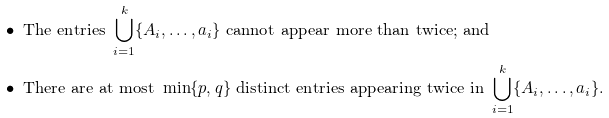<formula> <loc_0><loc_0><loc_500><loc_500>& \bullet \ \text {The entries} \ \bigcup _ { i = 1 } ^ { k } \{ A _ { i } , \dots , a _ { i } \} \ \text {cannot appear more than twice; and} \\ & \bullet \ \text {There are at most} \ \min \{ p , q \} \ \text {distinct entries appearing twice in} \ \bigcup _ { i = 1 } ^ { k } \{ A _ { i } , \dots , a _ { i } \} .</formula> 